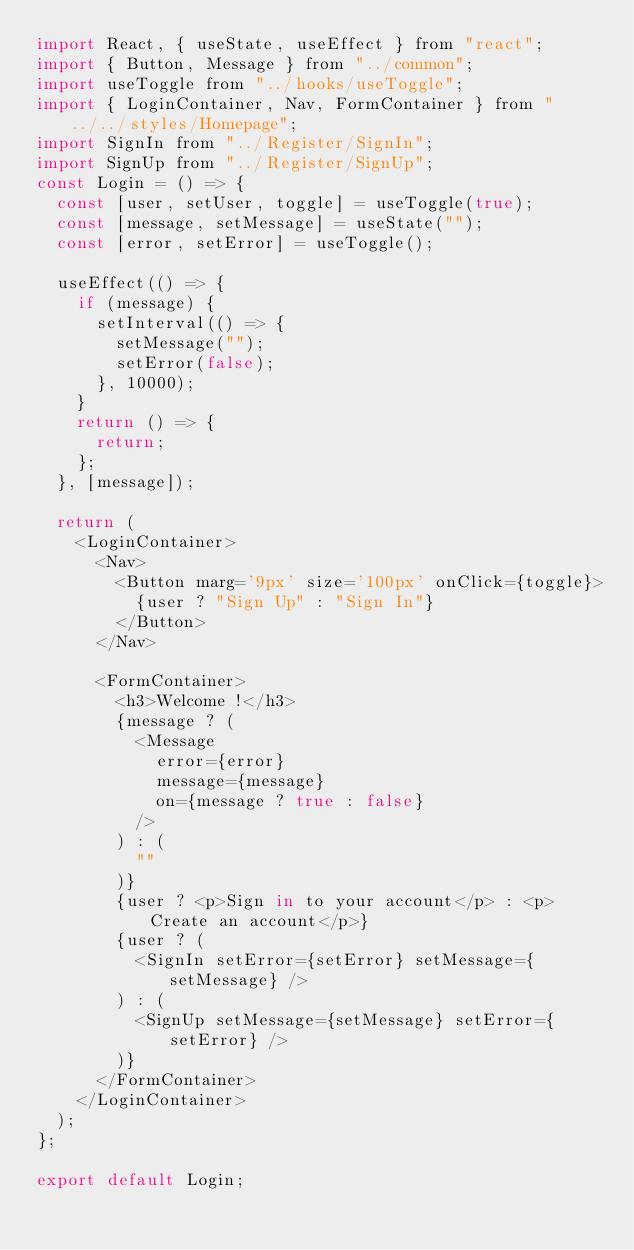Convert code to text. <code><loc_0><loc_0><loc_500><loc_500><_JavaScript_>import React, { useState, useEffect } from "react";
import { Button, Message } from "../common";
import useToggle from "../hooks/useToggle";
import { LoginContainer, Nav, FormContainer } from "../../styles/Homepage";
import SignIn from "../Register/SignIn";
import SignUp from "../Register/SignUp";
const Login = () => {
  const [user, setUser, toggle] = useToggle(true);
  const [message, setMessage] = useState("");
  const [error, setError] = useToggle();

  useEffect(() => {
    if (message) {
      setInterval(() => {
        setMessage("");
        setError(false);
      }, 10000);
    }
    return () => {
      return;
    };
  }, [message]);

  return (
    <LoginContainer>
      <Nav>
        <Button marg='9px' size='100px' onClick={toggle}>
          {user ? "Sign Up" : "Sign In"}
        </Button>
      </Nav>

      <FormContainer>
        <h3>Welcome !</h3>
        {message ? (
          <Message
            error={error}
            message={message}
            on={message ? true : false}
          />
        ) : (
          ""
        )}
        {user ? <p>Sign in to your account</p> : <p>Create an account</p>}
        {user ? (
          <SignIn setError={setError} setMessage={setMessage} />
        ) : (
          <SignUp setMessage={setMessage} setError={setError} />
        )}
      </FormContainer>
    </LoginContainer>
  );
};

export default Login;
</code> 